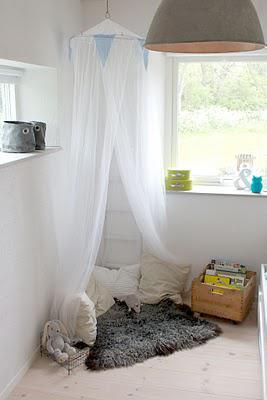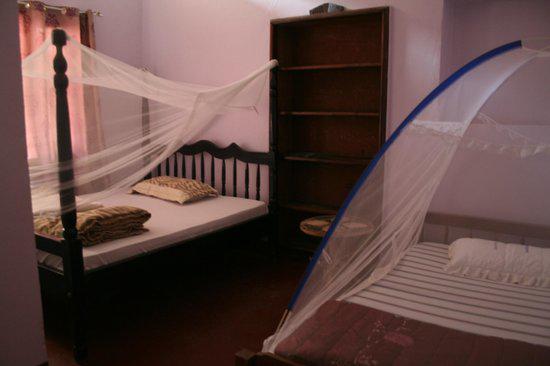The first image is the image on the left, the second image is the image on the right. Analyze the images presented: Is the assertion "At least one image shows a room with multiple beds equipped with some type of protective screens." valid? Answer yes or no. Yes. The first image is the image on the left, the second image is the image on the right. Evaluate the accuracy of this statement regarding the images: "There are two beds in one of the images.". Is it true? Answer yes or no. Yes. 